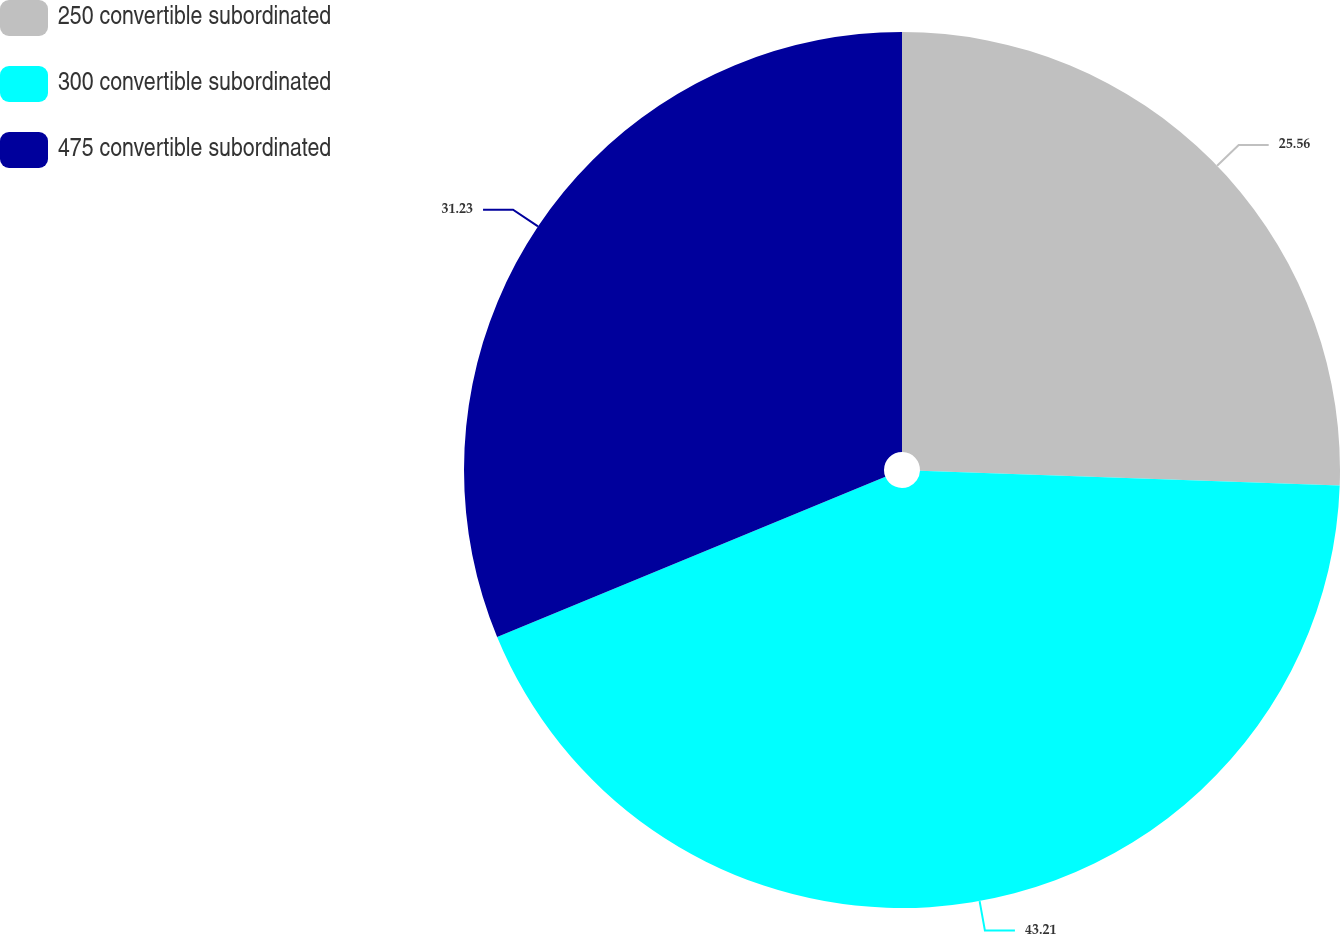Convert chart. <chart><loc_0><loc_0><loc_500><loc_500><pie_chart><fcel>250 convertible subordinated<fcel>300 convertible subordinated<fcel>475 convertible subordinated<nl><fcel>25.56%<fcel>43.21%<fcel>31.23%<nl></chart> 